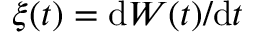Convert formula to latex. <formula><loc_0><loc_0><loc_500><loc_500>\xi ( t ) = d W ( t ) / d t</formula> 